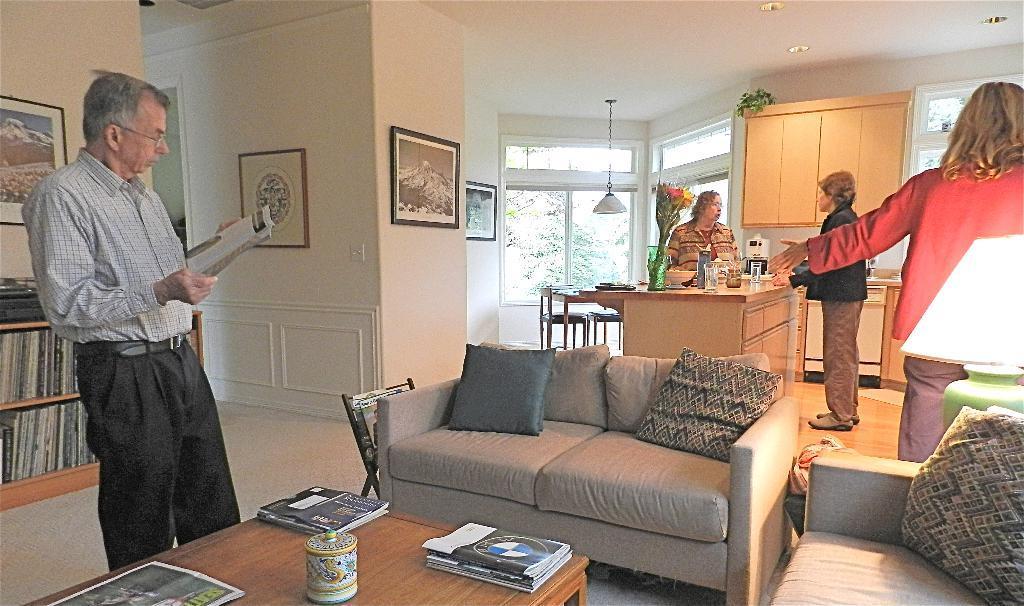In one or two sentences, can you explain what this image depicts? In this picture we can see some persons are standing on the floor. This is sofa and there are pillows. Here we can see a table. On the table there are some books. On the background we can see a flower vase and these are the chairs. This is wall and there are frames. 